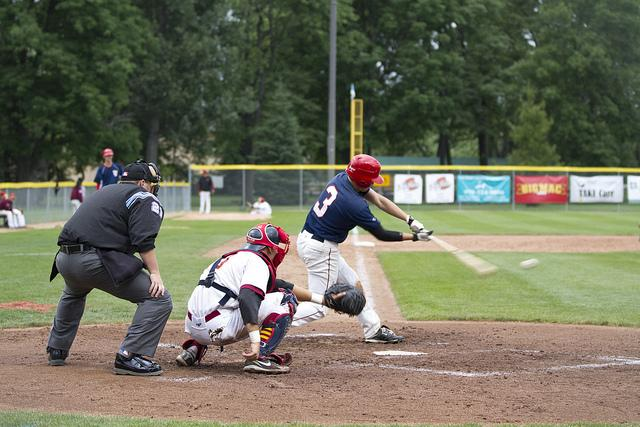What happens in the ball goes over the yellow barrier? home run 